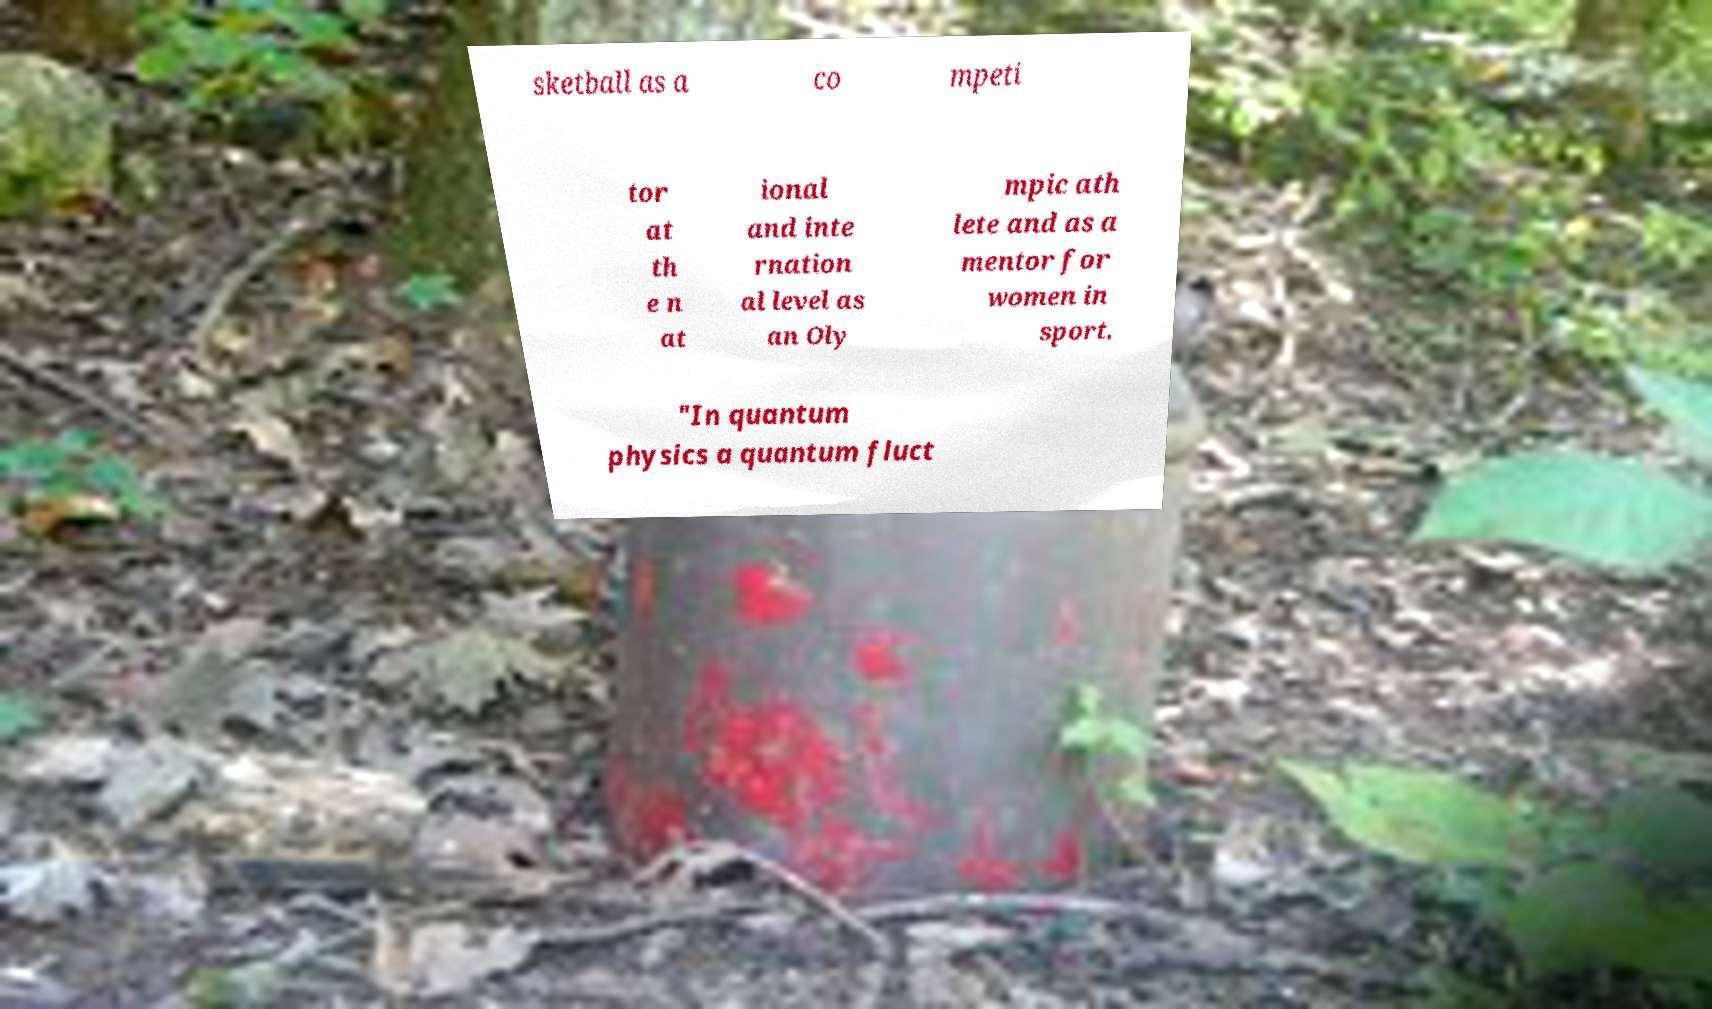Please read and relay the text visible in this image. What does it say? sketball as a co mpeti tor at th e n at ional and inte rnation al level as an Oly mpic ath lete and as a mentor for women in sport. "In quantum physics a quantum fluct 